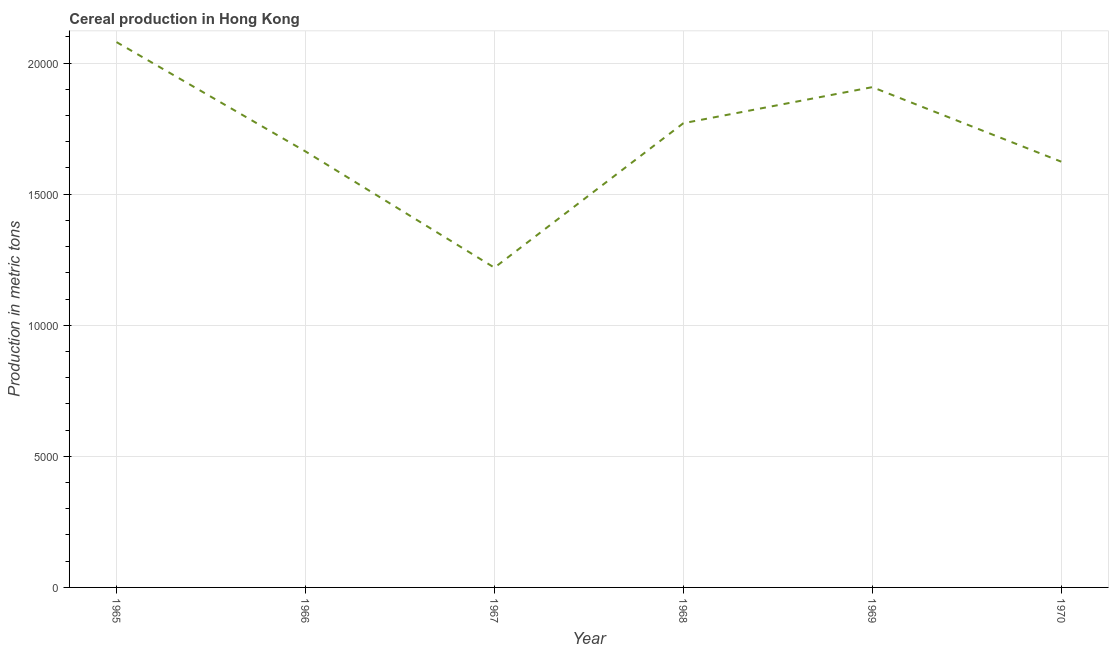What is the cereal production in 1966?
Your response must be concise. 1.66e+04. Across all years, what is the maximum cereal production?
Keep it short and to the point. 2.08e+04. Across all years, what is the minimum cereal production?
Your response must be concise. 1.22e+04. In which year was the cereal production maximum?
Ensure brevity in your answer.  1965. In which year was the cereal production minimum?
Offer a terse response. 1967. What is the sum of the cereal production?
Make the answer very short. 1.03e+05. What is the difference between the cereal production in 1968 and 1970?
Offer a terse response. 1468. What is the average cereal production per year?
Your answer should be compact. 1.71e+04. What is the median cereal production?
Your answer should be very brief. 1.72e+04. In how many years, is the cereal production greater than 2000 metric tons?
Make the answer very short. 6. Do a majority of the years between 1966 and 1969 (inclusive) have cereal production greater than 10000 metric tons?
Ensure brevity in your answer.  Yes. What is the ratio of the cereal production in 1966 to that in 1968?
Keep it short and to the point. 0.94. Is the cereal production in 1969 less than that in 1970?
Offer a very short reply. No. What is the difference between the highest and the second highest cereal production?
Provide a succinct answer. 1718. What is the difference between the highest and the lowest cereal production?
Offer a terse response. 8604. In how many years, is the cereal production greater than the average cereal production taken over all years?
Provide a short and direct response. 3. How many lines are there?
Provide a succinct answer. 1. How many years are there in the graph?
Offer a very short reply. 6. What is the difference between two consecutive major ticks on the Y-axis?
Provide a succinct answer. 5000. What is the title of the graph?
Offer a terse response. Cereal production in Hong Kong. What is the label or title of the Y-axis?
Offer a terse response. Production in metric tons. What is the Production in metric tons of 1965?
Provide a succinct answer. 2.08e+04. What is the Production in metric tons of 1966?
Offer a very short reply. 1.66e+04. What is the Production in metric tons in 1967?
Provide a succinct answer. 1.22e+04. What is the Production in metric tons of 1968?
Offer a terse response. 1.77e+04. What is the Production in metric tons in 1969?
Offer a very short reply. 1.91e+04. What is the Production in metric tons of 1970?
Ensure brevity in your answer.  1.62e+04. What is the difference between the Production in metric tons in 1965 and 1966?
Your answer should be compact. 4170. What is the difference between the Production in metric tons in 1965 and 1967?
Offer a terse response. 8604. What is the difference between the Production in metric tons in 1965 and 1968?
Give a very brief answer. 3093. What is the difference between the Production in metric tons in 1965 and 1969?
Provide a short and direct response. 1718. What is the difference between the Production in metric tons in 1965 and 1970?
Provide a short and direct response. 4561. What is the difference between the Production in metric tons in 1966 and 1967?
Ensure brevity in your answer.  4434. What is the difference between the Production in metric tons in 1966 and 1968?
Provide a succinct answer. -1077. What is the difference between the Production in metric tons in 1966 and 1969?
Your response must be concise. -2452. What is the difference between the Production in metric tons in 1966 and 1970?
Offer a terse response. 391. What is the difference between the Production in metric tons in 1967 and 1968?
Ensure brevity in your answer.  -5511. What is the difference between the Production in metric tons in 1967 and 1969?
Provide a succinct answer. -6886. What is the difference between the Production in metric tons in 1967 and 1970?
Offer a terse response. -4043. What is the difference between the Production in metric tons in 1968 and 1969?
Offer a very short reply. -1375. What is the difference between the Production in metric tons in 1968 and 1970?
Give a very brief answer. 1468. What is the difference between the Production in metric tons in 1969 and 1970?
Provide a succinct answer. 2843. What is the ratio of the Production in metric tons in 1965 to that in 1966?
Provide a succinct answer. 1.25. What is the ratio of the Production in metric tons in 1965 to that in 1967?
Provide a succinct answer. 1.71. What is the ratio of the Production in metric tons in 1965 to that in 1968?
Provide a short and direct response. 1.18. What is the ratio of the Production in metric tons in 1965 to that in 1969?
Give a very brief answer. 1.09. What is the ratio of the Production in metric tons in 1965 to that in 1970?
Offer a terse response. 1.28. What is the ratio of the Production in metric tons in 1966 to that in 1967?
Make the answer very short. 1.36. What is the ratio of the Production in metric tons in 1966 to that in 1968?
Make the answer very short. 0.94. What is the ratio of the Production in metric tons in 1966 to that in 1969?
Offer a terse response. 0.87. What is the ratio of the Production in metric tons in 1967 to that in 1968?
Ensure brevity in your answer.  0.69. What is the ratio of the Production in metric tons in 1967 to that in 1969?
Your answer should be compact. 0.64. What is the ratio of the Production in metric tons in 1967 to that in 1970?
Provide a succinct answer. 0.75. What is the ratio of the Production in metric tons in 1968 to that in 1969?
Offer a terse response. 0.93. What is the ratio of the Production in metric tons in 1968 to that in 1970?
Give a very brief answer. 1.09. What is the ratio of the Production in metric tons in 1969 to that in 1970?
Provide a short and direct response. 1.18. 